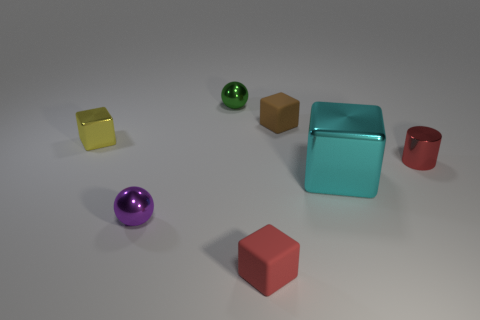Add 1 yellow things. How many objects exist? 8 Subtract all cylinders. How many objects are left? 6 Subtract 1 red blocks. How many objects are left? 6 Subtract all yellow metal things. Subtract all large green spheres. How many objects are left? 6 Add 5 red rubber things. How many red rubber things are left? 6 Add 1 tiny gray matte cubes. How many tiny gray matte cubes exist? 1 